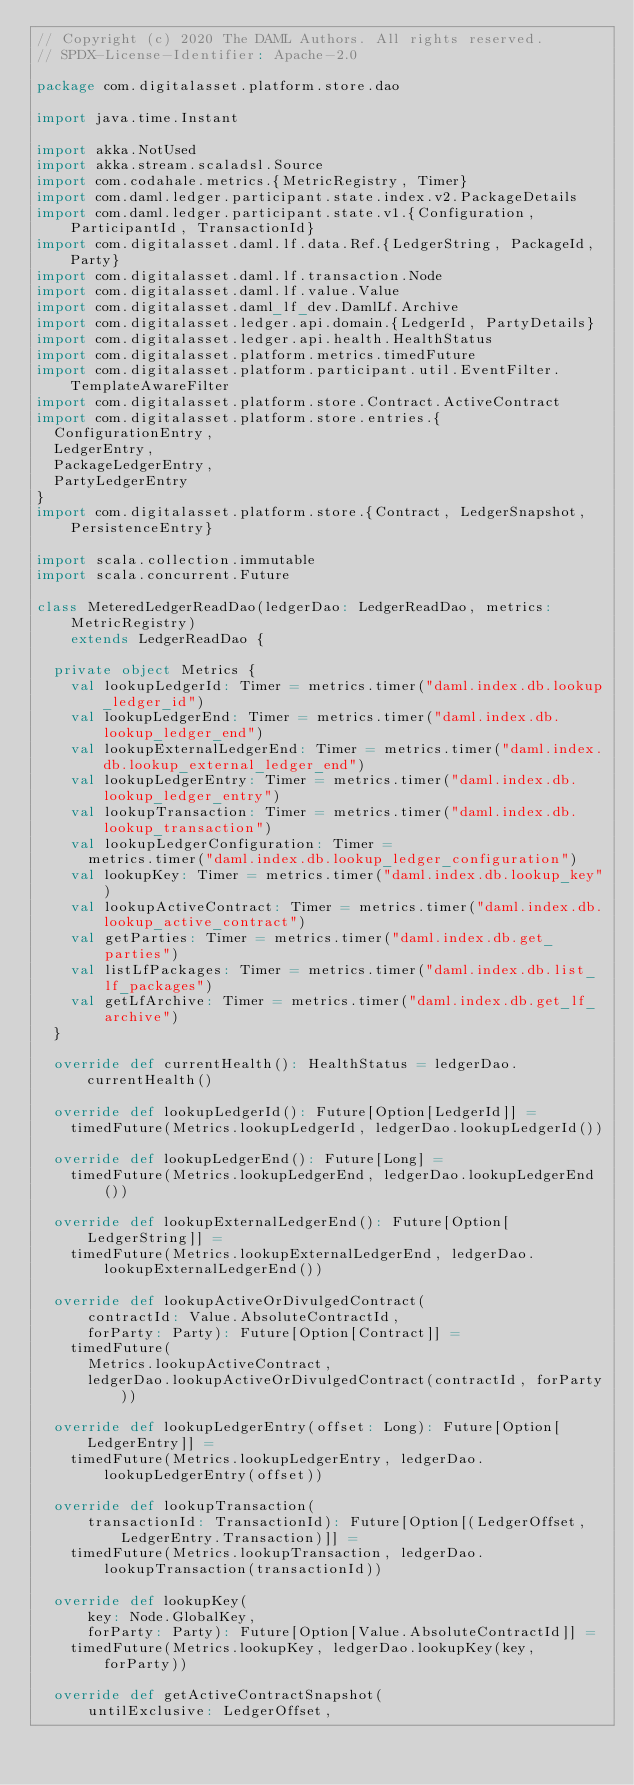<code> <loc_0><loc_0><loc_500><loc_500><_Scala_>// Copyright (c) 2020 The DAML Authors. All rights reserved.
// SPDX-License-Identifier: Apache-2.0

package com.digitalasset.platform.store.dao

import java.time.Instant

import akka.NotUsed
import akka.stream.scaladsl.Source
import com.codahale.metrics.{MetricRegistry, Timer}
import com.daml.ledger.participant.state.index.v2.PackageDetails
import com.daml.ledger.participant.state.v1.{Configuration, ParticipantId, TransactionId}
import com.digitalasset.daml.lf.data.Ref.{LedgerString, PackageId, Party}
import com.digitalasset.daml.lf.transaction.Node
import com.digitalasset.daml.lf.value.Value
import com.digitalasset.daml_lf_dev.DamlLf.Archive
import com.digitalasset.ledger.api.domain.{LedgerId, PartyDetails}
import com.digitalasset.ledger.api.health.HealthStatus
import com.digitalasset.platform.metrics.timedFuture
import com.digitalasset.platform.participant.util.EventFilter.TemplateAwareFilter
import com.digitalasset.platform.store.Contract.ActiveContract
import com.digitalasset.platform.store.entries.{
  ConfigurationEntry,
  LedgerEntry,
  PackageLedgerEntry,
  PartyLedgerEntry
}
import com.digitalasset.platform.store.{Contract, LedgerSnapshot, PersistenceEntry}

import scala.collection.immutable
import scala.concurrent.Future

class MeteredLedgerReadDao(ledgerDao: LedgerReadDao, metrics: MetricRegistry)
    extends LedgerReadDao {

  private object Metrics {
    val lookupLedgerId: Timer = metrics.timer("daml.index.db.lookup_ledger_id")
    val lookupLedgerEnd: Timer = metrics.timer("daml.index.db.lookup_ledger_end")
    val lookupExternalLedgerEnd: Timer = metrics.timer("daml.index.db.lookup_external_ledger_end")
    val lookupLedgerEntry: Timer = metrics.timer("daml.index.db.lookup_ledger_entry")
    val lookupTransaction: Timer = metrics.timer("daml.index.db.lookup_transaction")
    val lookupLedgerConfiguration: Timer =
      metrics.timer("daml.index.db.lookup_ledger_configuration")
    val lookupKey: Timer = metrics.timer("daml.index.db.lookup_key")
    val lookupActiveContract: Timer = metrics.timer("daml.index.db.lookup_active_contract")
    val getParties: Timer = metrics.timer("daml.index.db.get_parties")
    val listLfPackages: Timer = metrics.timer("daml.index.db.list_lf_packages")
    val getLfArchive: Timer = metrics.timer("daml.index.db.get_lf_archive")
  }

  override def currentHealth(): HealthStatus = ledgerDao.currentHealth()

  override def lookupLedgerId(): Future[Option[LedgerId]] =
    timedFuture(Metrics.lookupLedgerId, ledgerDao.lookupLedgerId())

  override def lookupLedgerEnd(): Future[Long] =
    timedFuture(Metrics.lookupLedgerEnd, ledgerDao.lookupLedgerEnd())

  override def lookupExternalLedgerEnd(): Future[Option[LedgerString]] =
    timedFuture(Metrics.lookupExternalLedgerEnd, ledgerDao.lookupExternalLedgerEnd())

  override def lookupActiveOrDivulgedContract(
      contractId: Value.AbsoluteContractId,
      forParty: Party): Future[Option[Contract]] =
    timedFuture(
      Metrics.lookupActiveContract,
      ledgerDao.lookupActiveOrDivulgedContract(contractId, forParty))

  override def lookupLedgerEntry(offset: Long): Future[Option[LedgerEntry]] =
    timedFuture(Metrics.lookupLedgerEntry, ledgerDao.lookupLedgerEntry(offset))

  override def lookupTransaction(
      transactionId: TransactionId): Future[Option[(LedgerOffset, LedgerEntry.Transaction)]] =
    timedFuture(Metrics.lookupTransaction, ledgerDao.lookupTransaction(transactionId))

  override def lookupKey(
      key: Node.GlobalKey,
      forParty: Party): Future[Option[Value.AbsoluteContractId]] =
    timedFuture(Metrics.lookupKey, ledgerDao.lookupKey(key, forParty))

  override def getActiveContractSnapshot(
      untilExclusive: LedgerOffset,</code> 